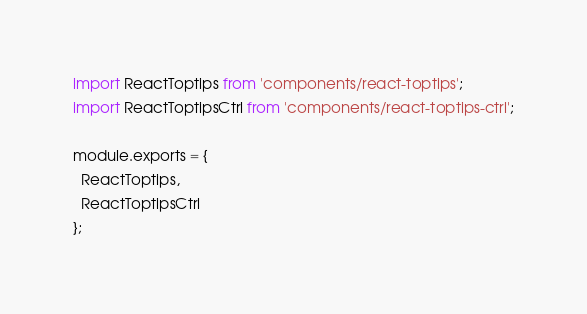<code> <loc_0><loc_0><loc_500><loc_500><_JavaScript_>import ReactToptips from 'components/react-toptips';
import ReactToptipsCtrl from 'components/react-toptips-ctrl';

module.exports = {
  ReactToptips,
  ReactToptipsCtrl
};
</code> 